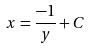Convert formula to latex. <formula><loc_0><loc_0><loc_500><loc_500>x = \frac { - 1 } { y } + C</formula> 